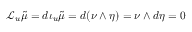<formula> <loc_0><loc_0><loc_500><loc_500>\mathcal { L } _ { u } { \tilde { \mu } } = d \iota _ { u } { \tilde { \mu } } = d ( \nu \wedge \eta ) = \nu \wedge d \eta = 0</formula> 